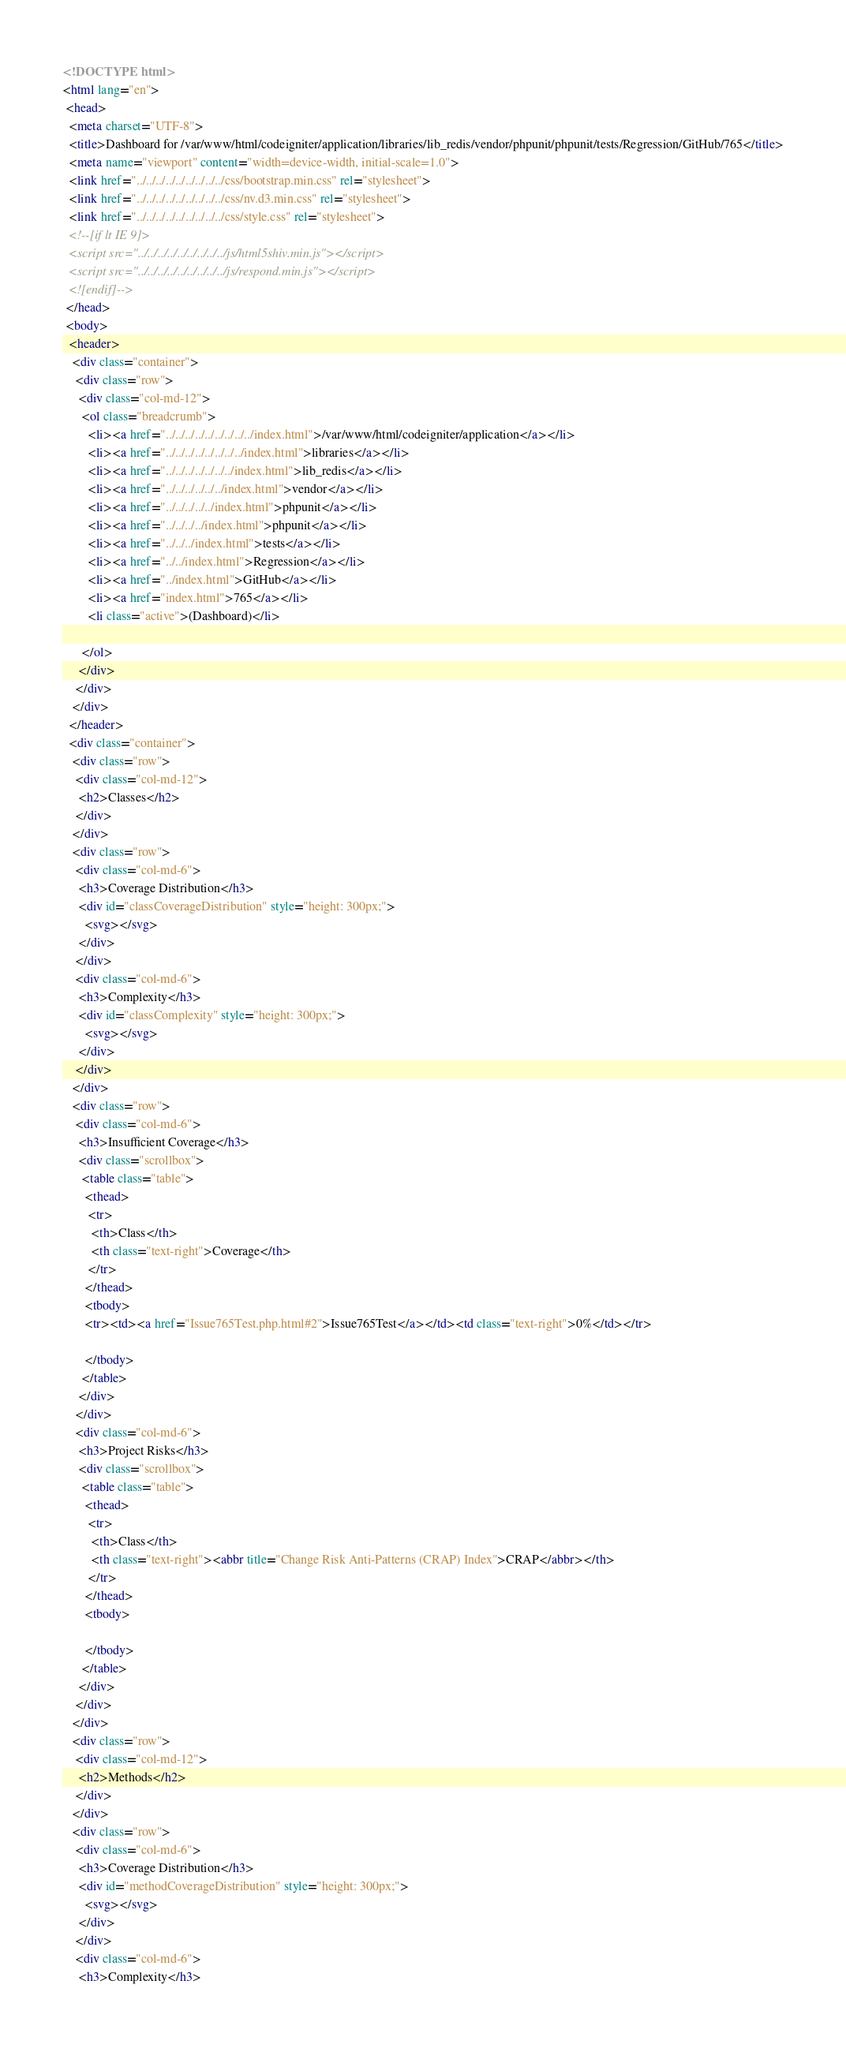<code> <loc_0><loc_0><loc_500><loc_500><_HTML_><!DOCTYPE html>
<html lang="en">
 <head>
  <meta charset="UTF-8">
  <title>Dashboard for /var/www/html/codeigniter/application/libraries/lib_redis/vendor/phpunit/phpunit/tests/Regression/GitHub/765</title>
  <meta name="viewport" content="width=device-width, initial-scale=1.0">
  <link href="../../../../../../../../../css/bootstrap.min.css" rel="stylesheet">
  <link href="../../../../../../../../../css/nv.d3.min.css" rel="stylesheet">
  <link href="../../../../../../../../../css/style.css" rel="stylesheet">
  <!--[if lt IE 9]>
  <script src="../../../../../../../../../js/html5shiv.min.js"></script>
  <script src="../../../../../../../../../js/respond.min.js"></script>
  <![endif]-->
 </head>
 <body>
  <header>
   <div class="container">
    <div class="row">
     <div class="col-md-12">
      <ol class="breadcrumb">
        <li><a href="../../../../../../../../../index.html">/var/www/html/codeigniter/application</a></li>
        <li><a href="../../../../../../../../index.html">libraries</a></li>
        <li><a href="../../../../../../../index.html">lib_redis</a></li>
        <li><a href="../../../../../../index.html">vendor</a></li>
        <li><a href="../../../../../index.html">phpunit</a></li>
        <li><a href="../../../../index.html">phpunit</a></li>
        <li><a href="../../../index.html">tests</a></li>
        <li><a href="../../index.html">Regression</a></li>
        <li><a href="../index.html">GitHub</a></li>
        <li><a href="index.html">765</a></li>
        <li class="active">(Dashboard)</li>

      </ol>
     </div>
    </div>
   </div>
  </header>
  <div class="container">
   <div class="row">
    <div class="col-md-12">
     <h2>Classes</h2>
    </div>
   </div>
   <div class="row">
    <div class="col-md-6">
     <h3>Coverage Distribution</h3>
     <div id="classCoverageDistribution" style="height: 300px;">
       <svg></svg>
     </div>
    </div>
    <div class="col-md-6">
     <h3>Complexity</h3>
     <div id="classComplexity" style="height: 300px;">
       <svg></svg>
     </div>
    </div>
   </div>
   <div class="row">
    <div class="col-md-6">
     <h3>Insufficient Coverage</h3>
     <div class="scrollbox">
      <table class="table">
       <thead>
        <tr>
         <th>Class</th>
         <th class="text-right">Coverage</th>
        </tr>
       </thead>
       <tbody>
       <tr><td><a href="Issue765Test.php.html#2">Issue765Test</a></td><td class="text-right">0%</td></tr>

       </tbody>
      </table>
     </div>
    </div>
    <div class="col-md-6">
     <h3>Project Risks</h3>
     <div class="scrollbox">
      <table class="table">
       <thead>
        <tr>
         <th>Class</th>
         <th class="text-right"><abbr title="Change Risk Anti-Patterns (CRAP) Index">CRAP</abbr></th>
        </tr>
       </thead>
       <tbody>

       </tbody>
      </table>
     </div>
    </div>
   </div>
   <div class="row">
    <div class="col-md-12">
     <h2>Methods</h2>
    </div>
   </div>
   <div class="row">
    <div class="col-md-6">
     <h3>Coverage Distribution</h3>
     <div id="methodCoverageDistribution" style="height: 300px;">
       <svg></svg>
     </div>
    </div>
    <div class="col-md-6">
     <h3>Complexity</h3></code> 